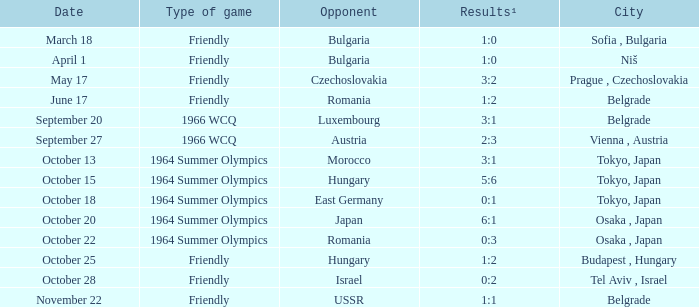What day were the results 3:2? May 17. 